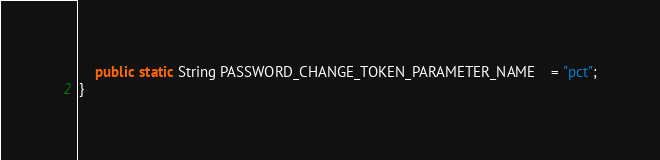Convert code to text. <code><loc_0><loc_0><loc_500><loc_500><_Java_>	public static String PASSWORD_CHANGE_TOKEN_PARAMETER_NAME	= "pct";
}
</code> 